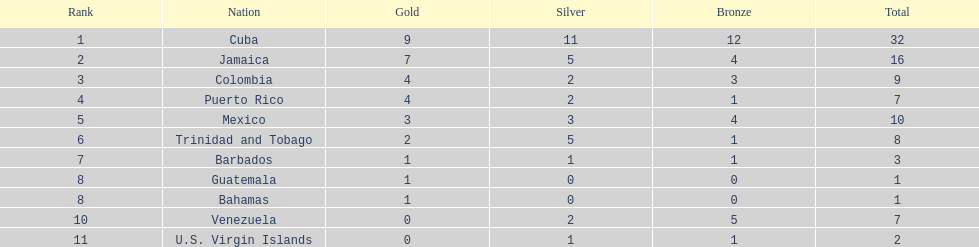Which teams won four gold medals? Colombia, Puerto Rico. Out of these two, which squad had only one bronze medal? Puerto Rico. 